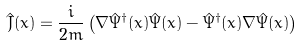Convert formula to latex. <formula><loc_0><loc_0><loc_500><loc_500>\hat { J } ( x ) = \frac { i } { 2 m } \left ( \nabla \hat { \Psi } ^ { \dag } ( x ) \hat { \Psi } ( x ) - \hat { \Psi } ^ { \dag } ( x ) \nabla \hat { \Psi } ( x ) \right )</formula> 